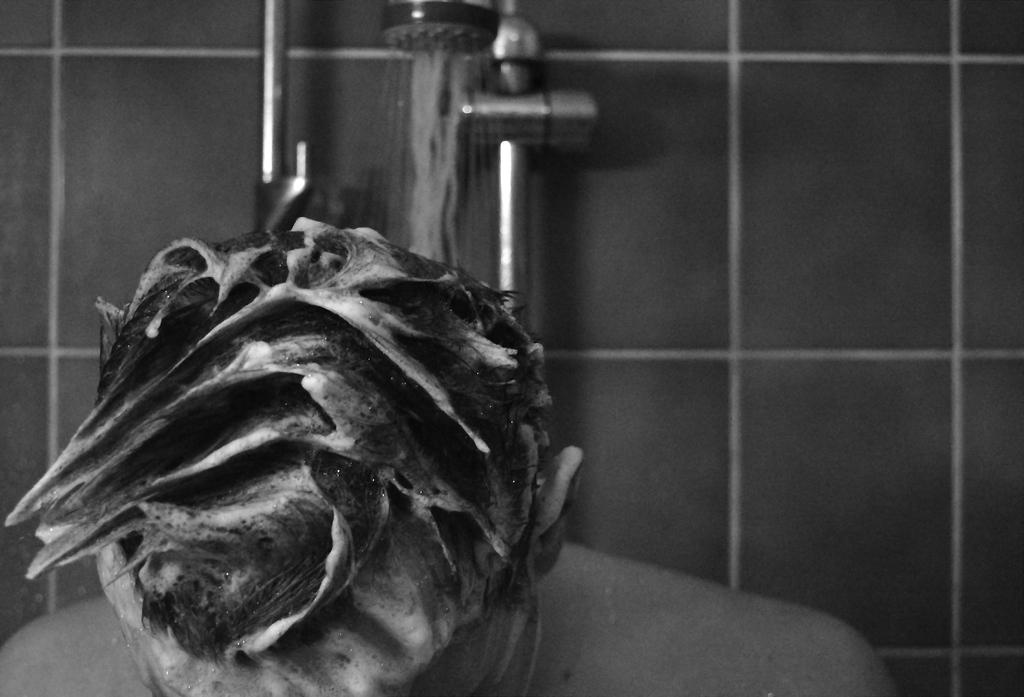Who or what is the main subject in the image? There is a person in the image. What can be seen in the background of the image? There is a wall and a shower in the background of the image. What is the price of the book on the shelf in the image? There is no book or shelf present in the image, so it is not possible to determine the price of a book. 